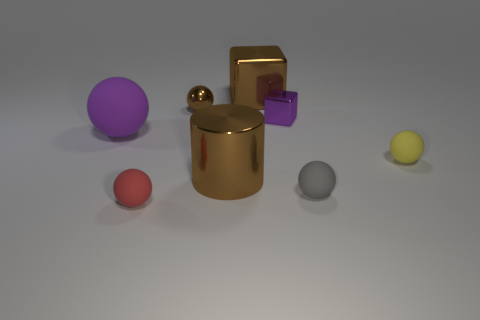Subtract 2 balls. How many balls are left? 3 Subtract all brown balls. How many balls are left? 4 Subtract all gray balls. How many balls are left? 4 Subtract all green spheres. Subtract all green cubes. How many spheres are left? 5 Add 1 tiny red matte balls. How many objects exist? 9 Subtract all cylinders. How many objects are left? 7 Add 8 big purple matte spheres. How many big purple matte spheres exist? 9 Subtract 0 blue cubes. How many objects are left? 8 Subtract all large brown metal cylinders. Subtract all brown metallic balls. How many objects are left? 6 Add 5 blocks. How many blocks are left? 7 